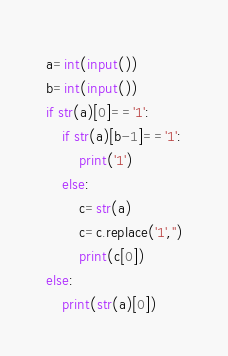<code> <loc_0><loc_0><loc_500><loc_500><_Python_>a=int(input())
b=int(input())
if str(a)[0]=='1':
    if str(a)[b-1]=='1':
        print('1')
    else:
        c=str(a)
        c=c.replace('1','')
        print(c[0])
else:
    print(str(a)[0])</code> 